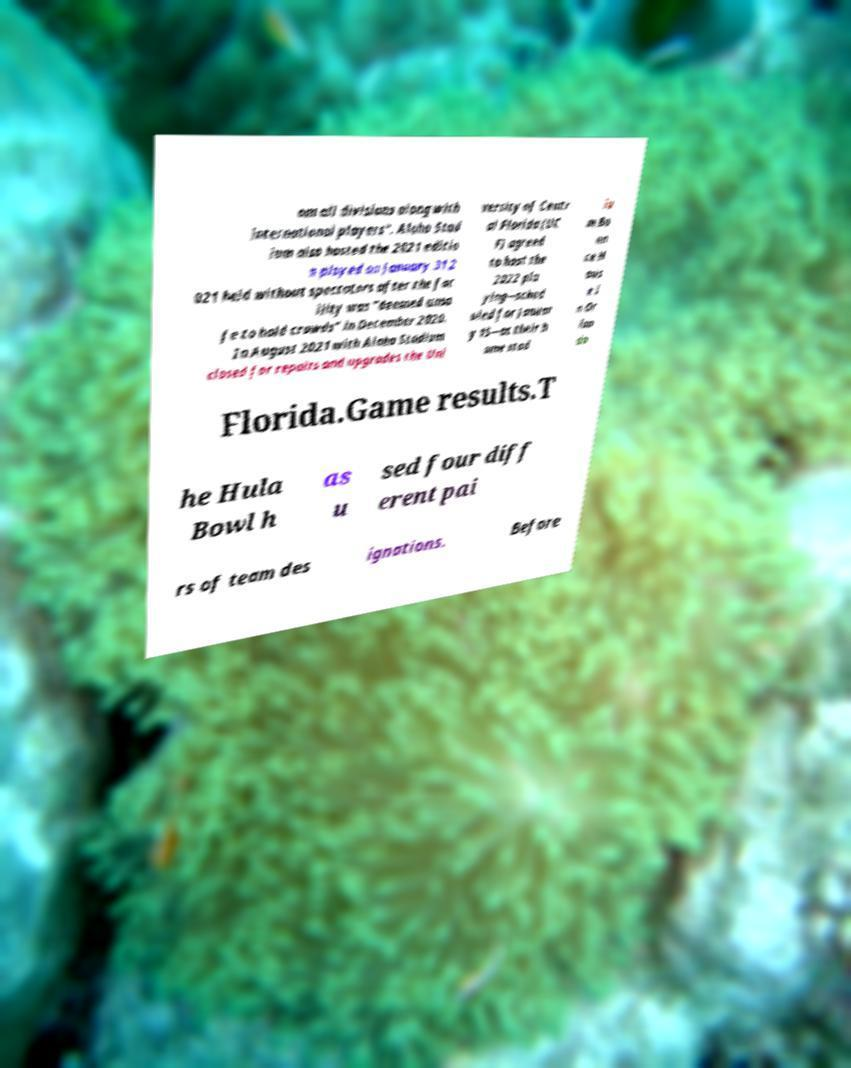What messages or text are displayed in this image? I need them in a readable, typed format. om all divisions along with international players". Aloha Stad ium also hosted the 2021 editio n played on January 31 2 021 held without spectators after the fac ility was "deemed unsa fe to hold crowds" in December 2020. In August 2021 with Aloha Stadium closed for repairs and upgrades the Uni versity of Centr al Florida (UC F) agreed to host the 2022 pla ying—sched uled for Januar y 15—at their h ome stad iu m Bo un ce H ous e i n Or lan do Florida.Game results.T he Hula Bowl h as u sed four diff erent pai rs of team des ignations. Before 